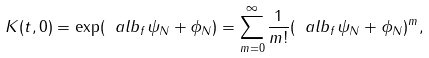Convert formula to latex. <formula><loc_0><loc_0><loc_500><loc_500>K ( t , 0 ) = \exp ( \ a l b _ { f } \psi _ { N } + \phi _ { N } ) = \sum _ { m = 0 } ^ { \infty } \frac { 1 } { m ! } ( \ a l b _ { f } \psi _ { N } + \phi _ { N } ) ^ { m } ,</formula> 